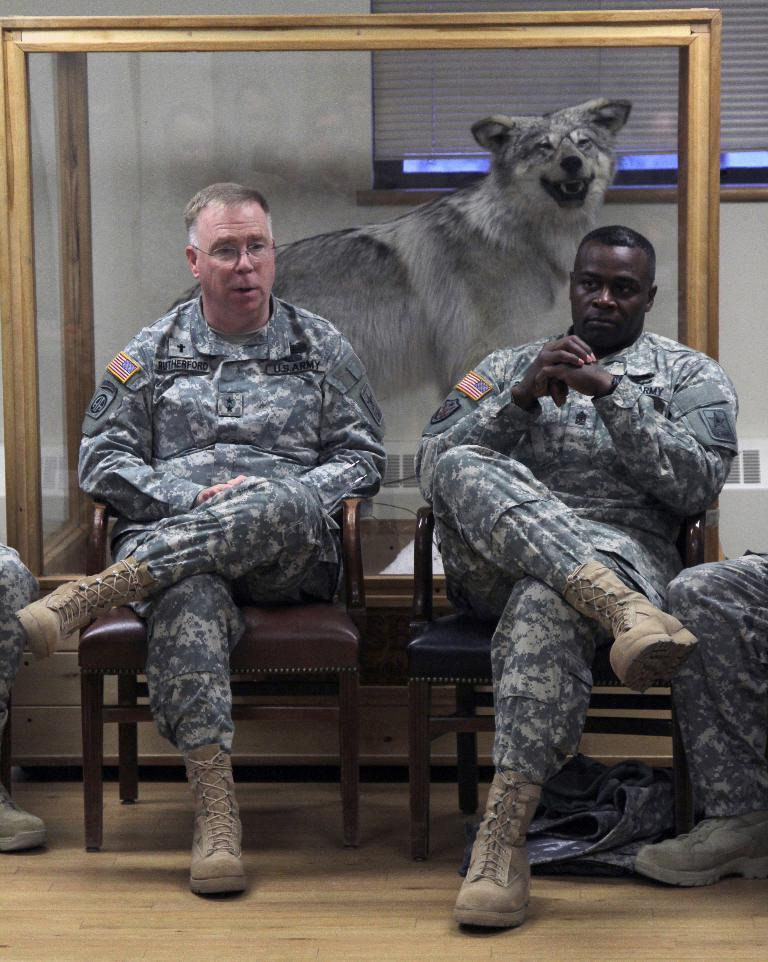What type of people can be seen in the image? There are soldiers in the image. What are the soldiers doing in the image? The soldiers are sitting on chairs. What can be seen in the background of the image? There is an animal, a wall, and a curtain in the background of the image. How many hands does the animal have in the image? The image does not show the animal's hands, as animals typically do not have hands. 